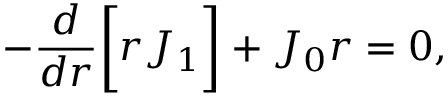Convert formula to latex. <formula><loc_0><loc_0><loc_500><loc_500>- \frac { d } { d r } \left [ r J _ { 1 } \right ] + J _ { 0 } r = 0 ,</formula> 